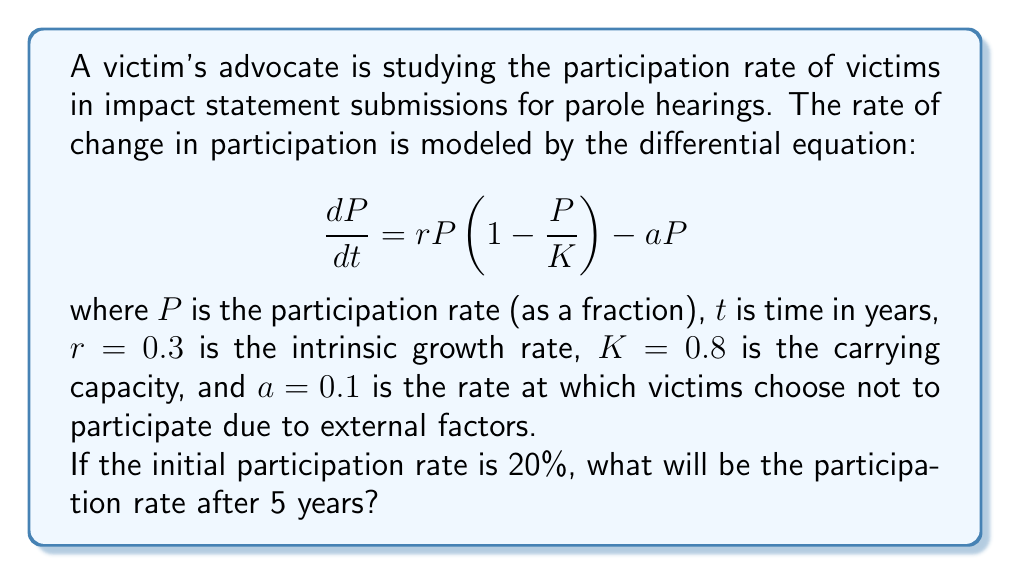Show me your answer to this math problem. To solve this problem, we need to follow these steps:

1) First, we recognize this as a logistic growth model with an additional term for attrition. The equation is a first-order nonlinear differential equation.

2) To solve this equation analytically is complex, so we'll use a numerical method. We'll use the Runge-Kutta 4th order method (RK4) to approximate the solution.

3) The RK4 method is given by:
   $$P_{n+1} = P_n + \frac{1}{6}(k_1 + 2k_2 + 2k_3 + k_4)$$
   where:
   $$k_1 = hf(t_n, P_n)$$
   $$k_2 = hf(t_n + \frac{h}{2}, P_n + \frac{k_1}{2})$$
   $$k_3 = hf(t_n + \frac{h}{2}, P_n + \frac{k_2}{2})$$
   $$k_4 = hf(t_n + h, P_n + k_3)$$

   and $f(t,P) = rP(1-\frac{P}{K}) - aP$

4) We'll use a step size of $h=0.1$ years, so we need to iterate 50 times to cover 5 years.

5) Initial conditions: $P_0 = 0.2$, $t_0 = 0$

6) Implementing the RK4 method (pseudo-code):
   ```
   for i = 1 to 50:
       k1 = h * f(t, P)
       k2 = h * f(t + h/2, P + k1/2)
       k3 = h * f(t + h/2, P + k2/2)
       k4 = h * f(t + h, P + k3)
       P = P + (k1 + 2*k2 + 2*k3 + k4) / 6
       t = t + h
   ```

7) After running this iteration 50 times, we get the final participation rate.
Answer: $P \approx 0.3978$ or $39.78\%$ 